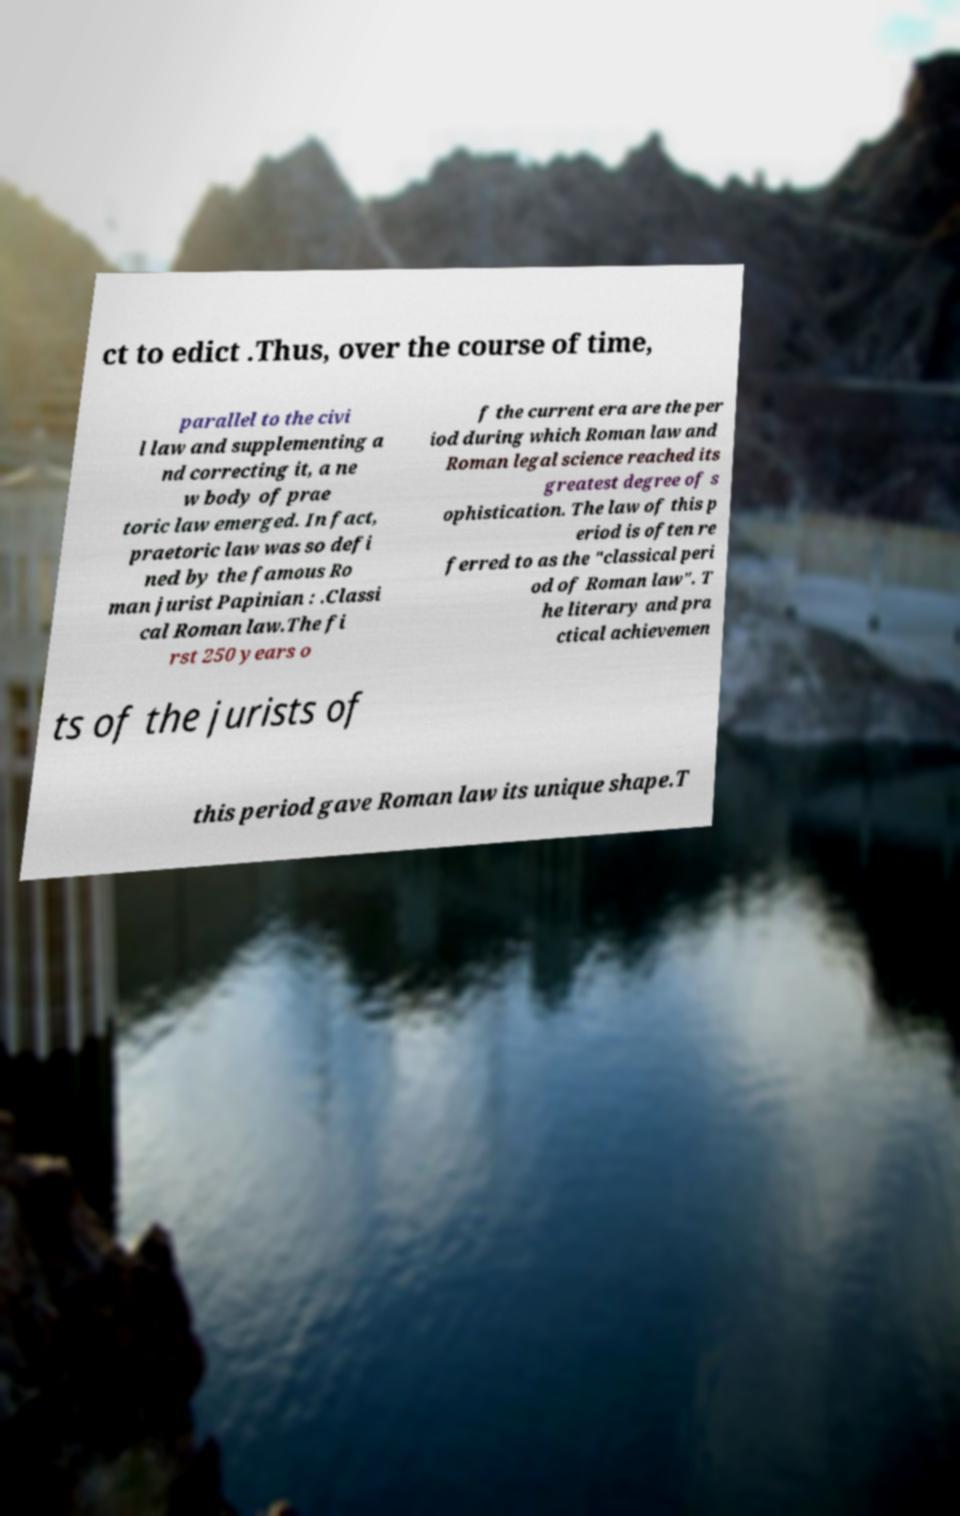What messages or text are displayed in this image? I need them in a readable, typed format. ct to edict .Thus, over the course of time, parallel to the civi l law and supplementing a nd correcting it, a ne w body of prae toric law emerged. In fact, praetoric law was so defi ned by the famous Ro man jurist Papinian : .Classi cal Roman law.The fi rst 250 years o f the current era are the per iod during which Roman law and Roman legal science reached its greatest degree of s ophistication. The law of this p eriod is often re ferred to as the "classical peri od of Roman law". T he literary and pra ctical achievemen ts of the jurists of this period gave Roman law its unique shape.T 